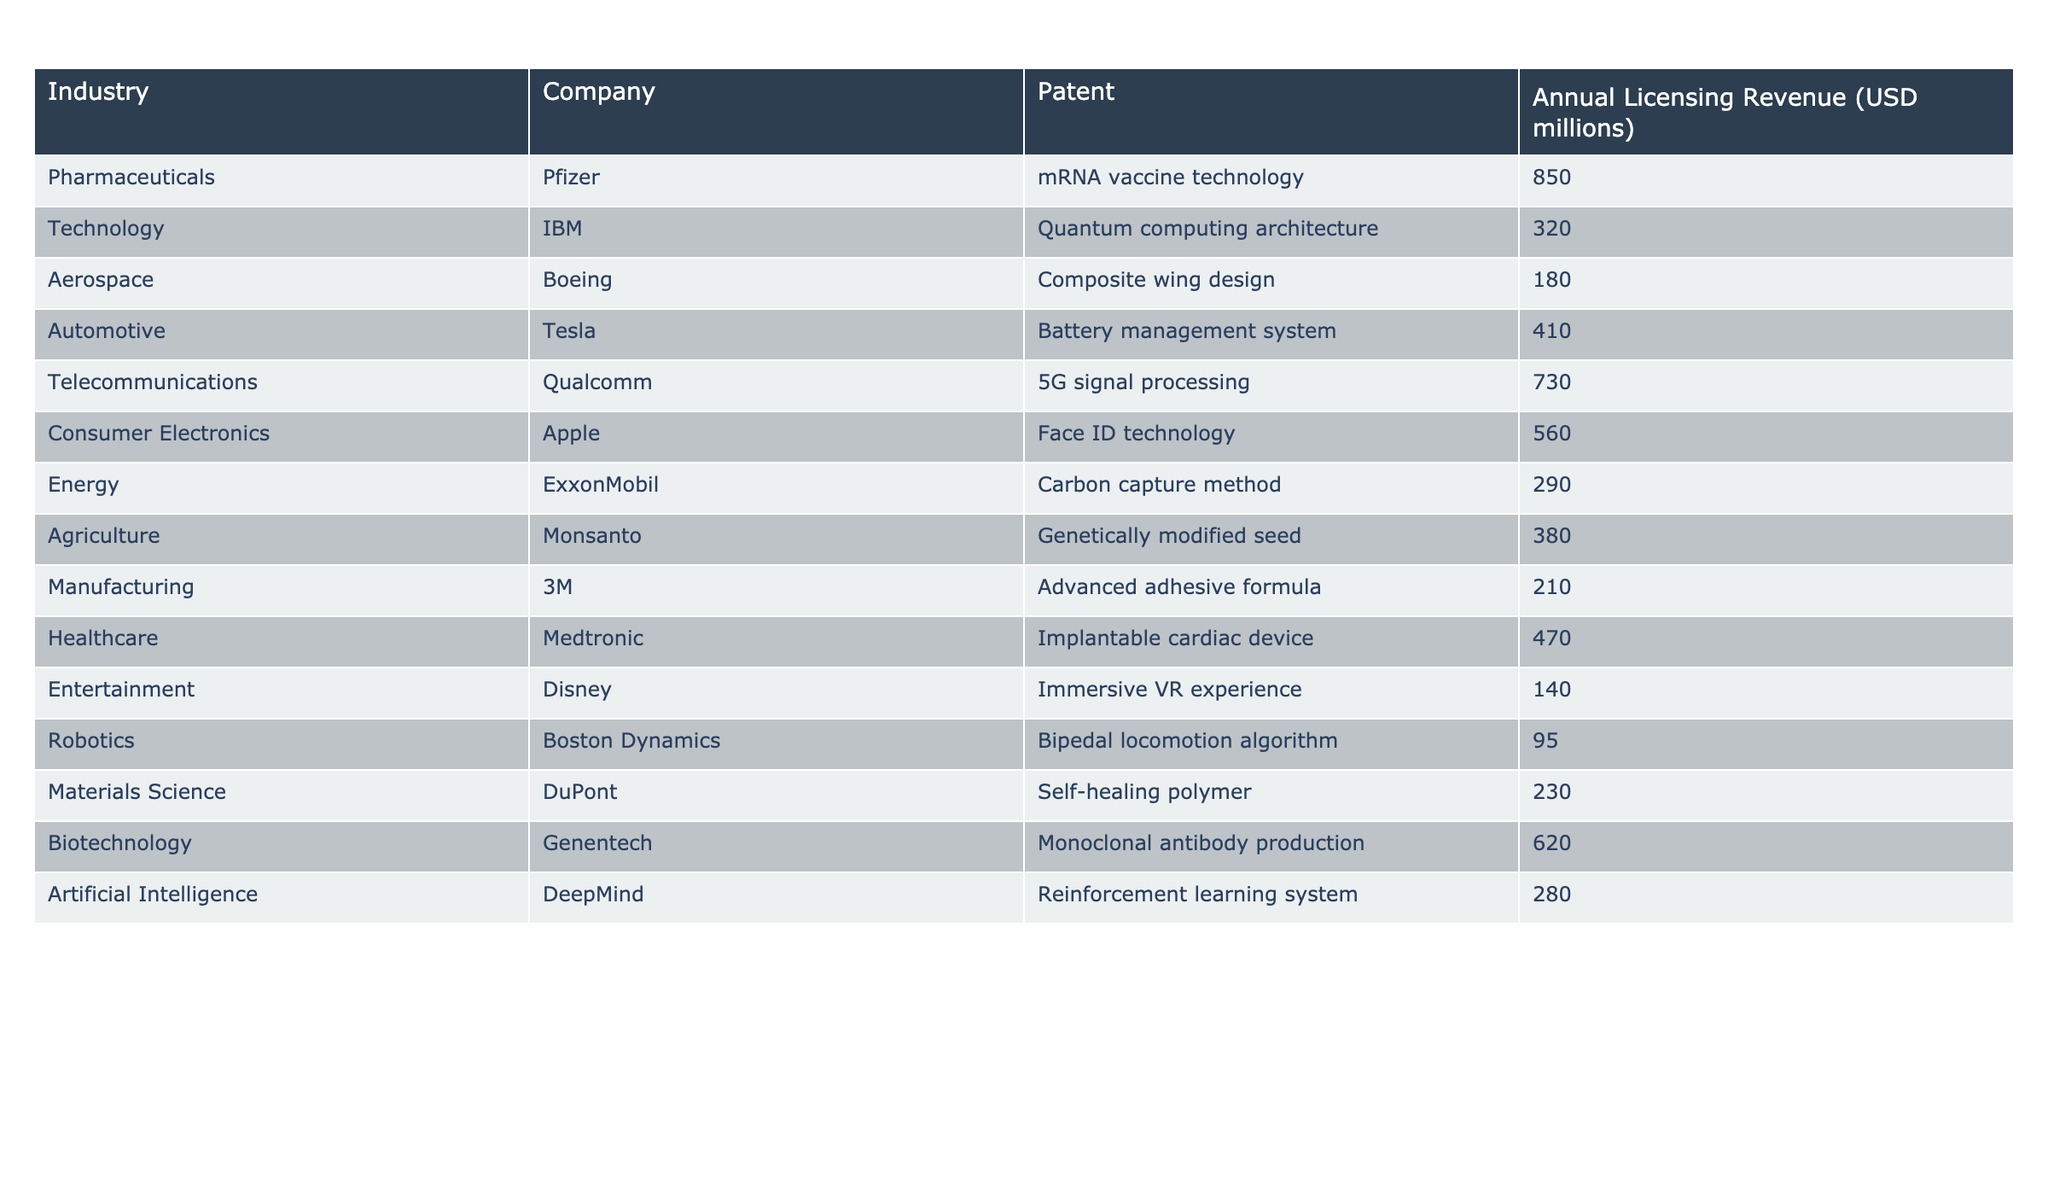What is the annual licensing revenue generated by Qualcomm's patent? According to the table, Qualcomm's patent, which is related to 5G signal processing, has an annual licensing revenue of 730 million USD.
Answer: 730 million USD Which company has the highest licensing revenue from patented inventions? The table shows that Pfizer's mRNA vaccine technology generates the highest licensing revenue at 850 million USD, compared to others in the table.
Answer: Pfizer What is the total licensing revenue generated by the Aerospace and Automotive industries? The licensing revenue for Aerospace (Boeing: 180 million USD) and Automotive (Tesla: 410 million USD) can be summed: 180 + 410 = 590 million USD.
Answer: 590 million USD Is there a company in the Robotics industry that generates more than 100 million USD in licensing revenue? The table lists Boston Dynamics in Robotics with a licensing revenue of 95 million USD, which is not more than 100 million USD. Therefore, the answer is no.
Answer: No What is the average licensing revenue of the Technology and Consumer Electronics industries? The revenue from Technology (IBM: 320 million USD) plus Consumer Electronics (Apple: 560 million USD) is 320 + 560 = 880 million USD. There are 2 companies, so the average is 880 / 2 = 440 million USD.
Answer: 440 million USD Which industry has the lowest annual licensing revenue, and what is that revenue? Looking at the table, the Robotics industry has the lowest revenue with Boston Dynamics generating only 95 million USD from its patent.
Answer: Robotics, 95 million USD How much more licensing revenue does the Biotechnology industry generate compared to the Manufacturing industry? The Biotechnology industry (Genentech: 620 million USD) generates 620 million USD, while Manufacturing (3M: 210 million USD) generates 210 million USD. The difference is 620 - 210 = 410 million USD.
Answer: 410 million USD Is the licensing revenue generated by the Energy industry greater than that of the Entertainment industry? The Energy industry (ExxonMobil: 290 million USD) generates less than the Entertainment industry (Disney: 140 million USD), thus the statement is false.
Answer: No What are the total licensing revenues from the Pharmaceutical and Healthcare industries combined? The licensing revenue for Pharmaceuticals (Pfizer: 850 million USD) and Healthcare (Medtronic: 470 million USD) summed up is 850 + 470 = 1320 million USD.
Answer: 1320 million USD Which company earns exactly 280 million USD in licensing revenue? The table shows that DeepMind from the Artificial Intelligence industry generates exactly 280 million USD from its patent.
Answer: DeepMind 